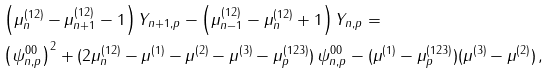<formula> <loc_0><loc_0><loc_500><loc_500>& \left ( \mu _ { n } ^ { ( 1 2 ) } - \mu _ { n + 1 } ^ { ( 1 2 ) } - 1 \right ) Y _ { n + 1 , p } - \left ( \mu _ { n - 1 } ^ { ( 1 2 ) } - \mu _ { n } ^ { ( 1 2 ) } + 1 \right ) Y _ { n , p } = \\ & \left ( \psi ^ { 0 0 } _ { n , p } \right ) ^ { 2 } + ( 2 \mu _ { n } ^ { ( 1 2 ) } - \mu ^ { ( 1 ) } - \mu ^ { ( 2 ) } - \mu ^ { ( 3 ) } - \mu _ { p } ^ { ( 1 2 3 ) } ) \, \psi ^ { 0 0 } _ { n , p } - ( \mu ^ { ( 1 ) } - \mu _ { p } ^ { ( 1 2 3 ) } ) ( \mu ^ { ( 3 ) } - \mu ^ { ( 2 ) } ) \, ,</formula> 